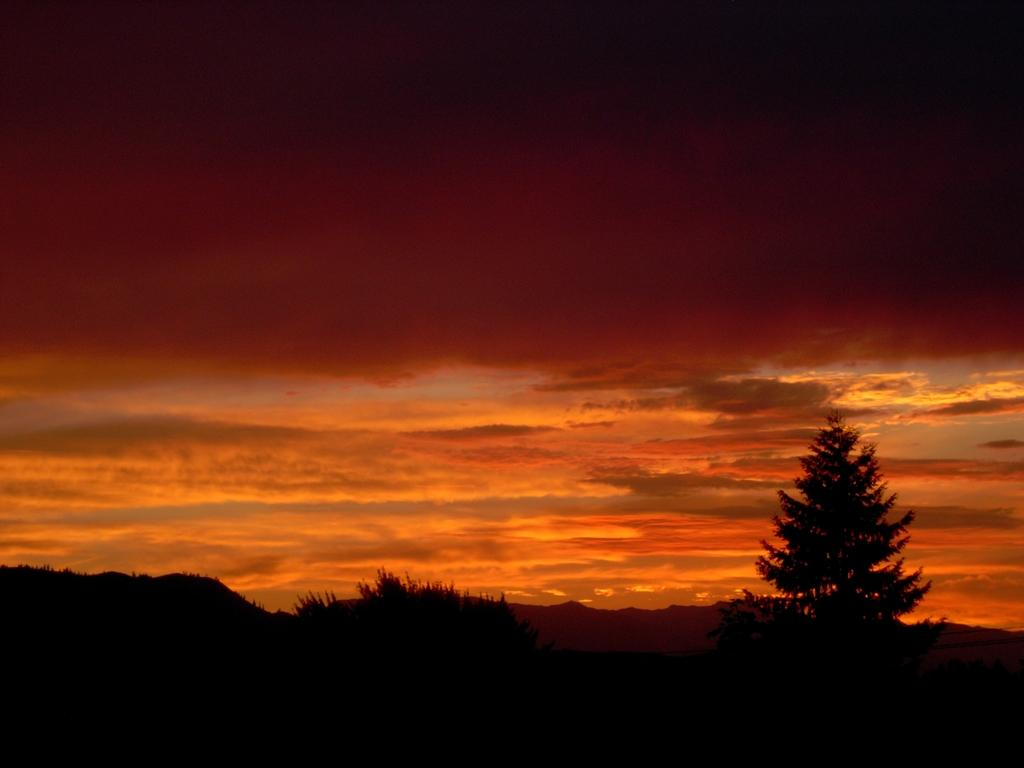What time of day is depicted in the image? The image appears to depict a sunset. What color is the sky in the image? The sky is in an orange color. What type of vegetation can be seen under the sky? There are trees visible under the sky. What type of coil is used to create the sunset effect in the image? There is no coil present in the image, and the sunset effect is a natural occurrence. How many flowers can be seen in the image? There are no flowers visible in the image; it primarily features a sunset sky and trees. 